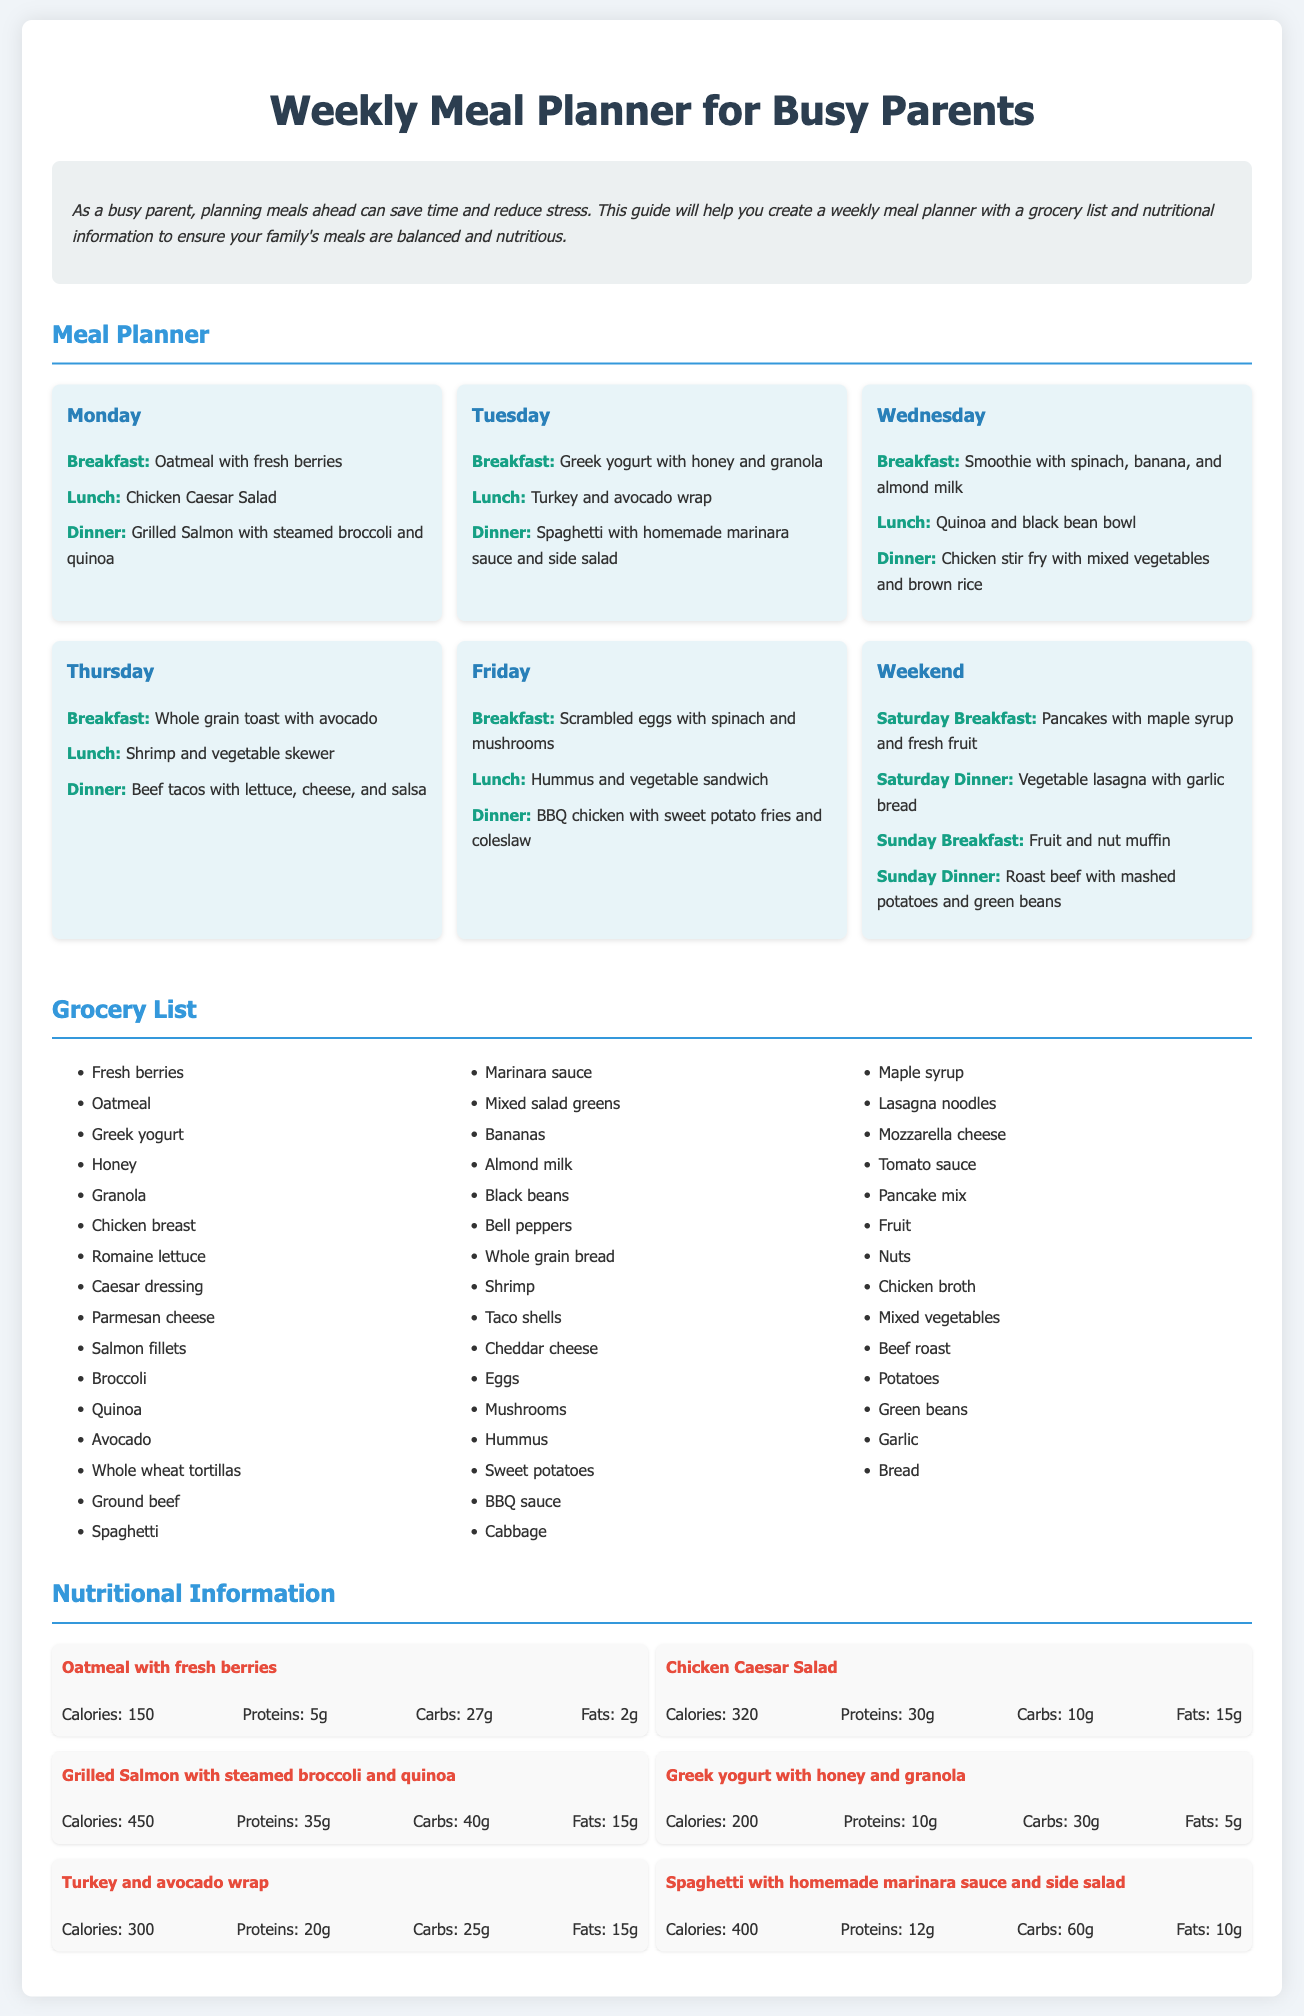What is the title of the document? The title of the document is located in the `<title>` tag and is "Weekly Meal Planner for Busy Parents."
Answer: Weekly Meal Planner for Busy Parents How many meals are planned for Wednesday? Each day of the meal planner includes three meals: breakfast, lunch, and dinner. Wednesday has a total of three meals listed.
Answer: 3 What is included in the grocery list that is related to breakfast? The grocery list contains several items; specifically, "Oatmeal," "Fresh berries," "Greek yogurt," "Honey," "Granola," "Eggs," and "Bananas" are breakfast-related items.
Answer: Oatmeal, Fresh berries, Greek yogurt, Honey, Granola, Eggs, Bananas What meal has the highest calorie count? The meal with the highest calorie count is "Grilled Salmon with steamed broccoli and quinoa," which is detailed in the nutritional information section.
Answer: Grilled Salmon with steamed broccoli and quinoa What type of wrap is included in Tuesday's lunch? Tuesday's lunch specifically mentions a "Turkey and avocado wrap."
Answer: Turkey and avocado wrap On which day is the vegetable lasagna served? The vegetable lasagna is mentioned for Saturday dinner in the meal planner section.
Answer: Saturday How many grams of protein does the Chicken Caesar Salad have? The nutritional details for the Chicken Caesar Salad state that it has 30 grams of protein.
Answer: 30g What type of cheese is listed in the grocery list? The grocery list features "Parmesan cheese" and "Cheddar cheese."
Answer: Parmesan cheese, Cheddar cheese What is the purpose of this document? The purpose is outlined in the introduction, which emphasizes meal planning for busy parents to save time and reduce stress.
Answer: Meal planning for busy parents 